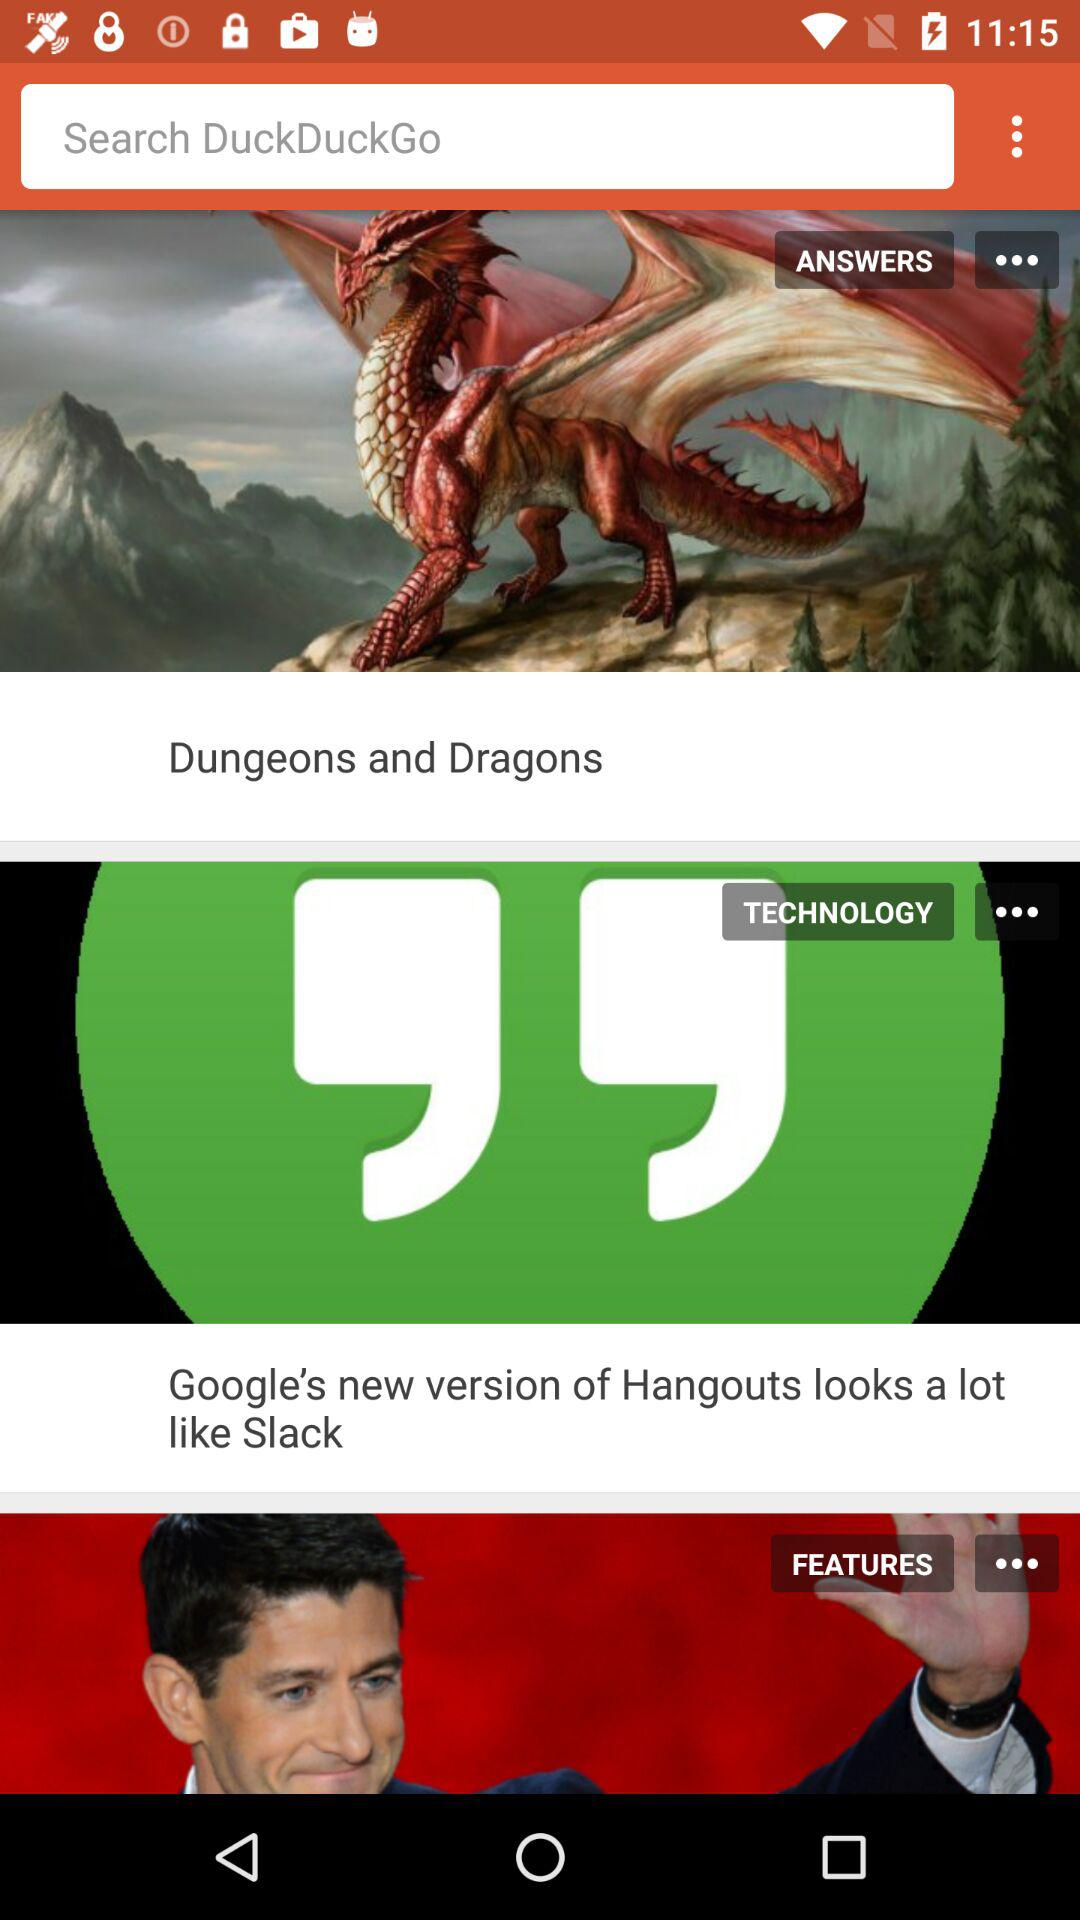What is the application name? The application name is "DuckDuckGo". 